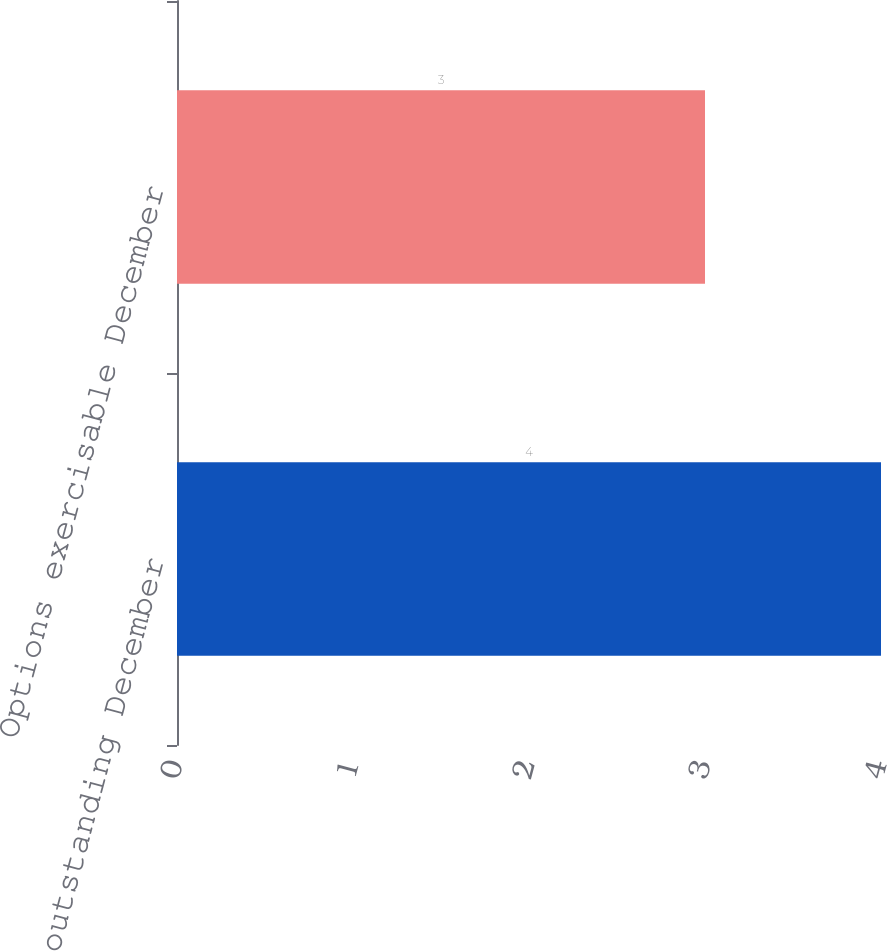Convert chart to OTSL. <chart><loc_0><loc_0><loc_500><loc_500><bar_chart><fcel>Options outstanding December<fcel>Options exercisable December<nl><fcel>4<fcel>3<nl></chart> 